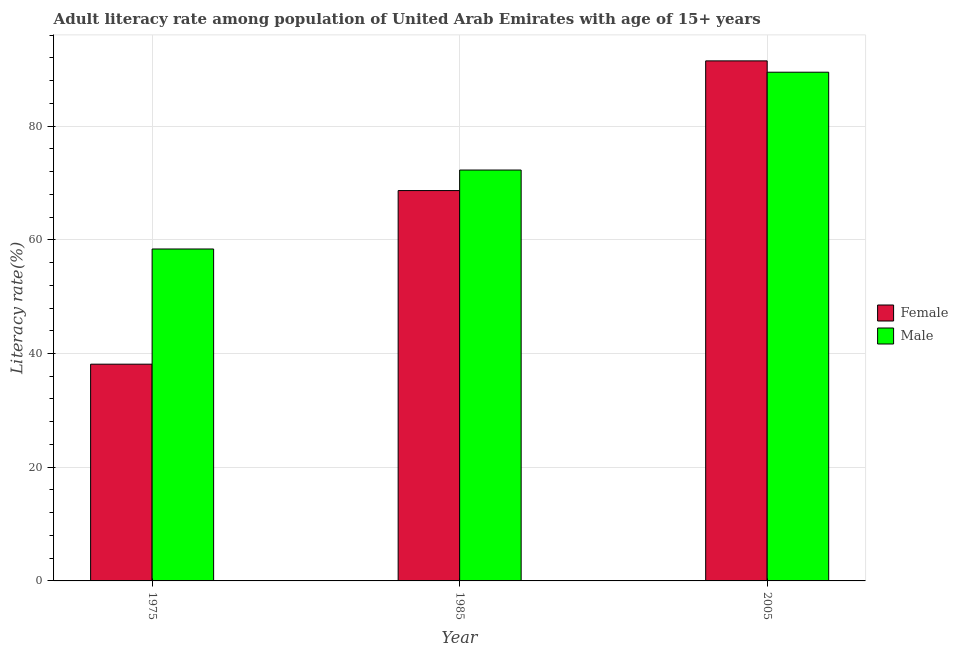How many different coloured bars are there?
Your answer should be very brief. 2. How many groups of bars are there?
Offer a terse response. 3. Are the number of bars per tick equal to the number of legend labels?
Ensure brevity in your answer.  Yes. Are the number of bars on each tick of the X-axis equal?
Your response must be concise. Yes. How many bars are there on the 1st tick from the right?
Provide a succinct answer. 2. What is the label of the 3rd group of bars from the left?
Your answer should be compact. 2005. In how many cases, is the number of bars for a given year not equal to the number of legend labels?
Give a very brief answer. 0. What is the male adult literacy rate in 1975?
Keep it short and to the point. 58.39. Across all years, what is the maximum female adult literacy rate?
Your answer should be very brief. 91.47. Across all years, what is the minimum male adult literacy rate?
Your answer should be compact. 58.39. In which year was the male adult literacy rate maximum?
Keep it short and to the point. 2005. In which year was the female adult literacy rate minimum?
Your answer should be compact. 1975. What is the total male adult literacy rate in the graph?
Provide a short and direct response. 220.14. What is the difference between the male adult literacy rate in 1985 and that in 2005?
Give a very brief answer. -17.21. What is the difference between the female adult literacy rate in 1975 and the male adult literacy rate in 2005?
Provide a short and direct response. -53.35. What is the average female adult literacy rate per year?
Keep it short and to the point. 66.09. In how many years, is the male adult literacy rate greater than 40 %?
Keep it short and to the point. 3. What is the ratio of the female adult literacy rate in 1975 to that in 2005?
Keep it short and to the point. 0.42. Is the male adult literacy rate in 1985 less than that in 2005?
Give a very brief answer. Yes. What is the difference between the highest and the second highest male adult literacy rate?
Keep it short and to the point. 17.21. What is the difference between the highest and the lowest male adult literacy rate?
Your answer should be compact. 31.1. Is the sum of the female adult literacy rate in 1975 and 2005 greater than the maximum male adult literacy rate across all years?
Offer a very short reply. Yes. What does the 1st bar from the left in 1975 represents?
Provide a short and direct response. Female. Are all the bars in the graph horizontal?
Make the answer very short. No. Are the values on the major ticks of Y-axis written in scientific E-notation?
Your response must be concise. No. Where does the legend appear in the graph?
Your response must be concise. Center right. How many legend labels are there?
Provide a short and direct response. 2. How are the legend labels stacked?
Make the answer very short. Vertical. What is the title of the graph?
Offer a very short reply. Adult literacy rate among population of United Arab Emirates with age of 15+ years. What is the label or title of the X-axis?
Give a very brief answer. Year. What is the label or title of the Y-axis?
Give a very brief answer. Literacy rate(%). What is the Literacy rate(%) in Female in 1975?
Your answer should be very brief. 38.12. What is the Literacy rate(%) in Male in 1975?
Your answer should be compact. 58.39. What is the Literacy rate(%) in Female in 1985?
Offer a very short reply. 68.66. What is the Literacy rate(%) in Male in 1985?
Give a very brief answer. 72.27. What is the Literacy rate(%) in Female in 2005?
Offer a very short reply. 91.47. What is the Literacy rate(%) in Male in 2005?
Offer a very short reply. 89.48. Across all years, what is the maximum Literacy rate(%) in Female?
Offer a very short reply. 91.47. Across all years, what is the maximum Literacy rate(%) in Male?
Provide a succinct answer. 89.48. Across all years, what is the minimum Literacy rate(%) of Female?
Your response must be concise. 38.12. Across all years, what is the minimum Literacy rate(%) of Male?
Keep it short and to the point. 58.39. What is the total Literacy rate(%) in Female in the graph?
Offer a terse response. 198.26. What is the total Literacy rate(%) of Male in the graph?
Make the answer very short. 220.14. What is the difference between the Literacy rate(%) in Female in 1975 and that in 1985?
Ensure brevity in your answer.  -30.54. What is the difference between the Literacy rate(%) of Male in 1975 and that in 1985?
Give a very brief answer. -13.89. What is the difference between the Literacy rate(%) of Female in 1975 and that in 2005?
Provide a succinct answer. -53.35. What is the difference between the Literacy rate(%) in Male in 1975 and that in 2005?
Make the answer very short. -31.1. What is the difference between the Literacy rate(%) of Female in 1985 and that in 2005?
Ensure brevity in your answer.  -22.81. What is the difference between the Literacy rate(%) of Male in 1985 and that in 2005?
Your answer should be compact. -17.21. What is the difference between the Literacy rate(%) of Female in 1975 and the Literacy rate(%) of Male in 1985?
Give a very brief answer. -34.15. What is the difference between the Literacy rate(%) in Female in 1975 and the Literacy rate(%) in Male in 2005?
Keep it short and to the point. -51.36. What is the difference between the Literacy rate(%) in Female in 1985 and the Literacy rate(%) in Male in 2005?
Offer a very short reply. -20.82. What is the average Literacy rate(%) of Female per year?
Your answer should be very brief. 66.09. What is the average Literacy rate(%) in Male per year?
Make the answer very short. 73.38. In the year 1975, what is the difference between the Literacy rate(%) of Female and Literacy rate(%) of Male?
Offer a terse response. -20.26. In the year 1985, what is the difference between the Literacy rate(%) of Female and Literacy rate(%) of Male?
Provide a short and direct response. -3.61. In the year 2005, what is the difference between the Literacy rate(%) of Female and Literacy rate(%) of Male?
Provide a short and direct response. 1.99. What is the ratio of the Literacy rate(%) of Female in 1975 to that in 1985?
Ensure brevity in your answer.  0.56. What is the ratio of the Literacy rate(%) in Male in 1975 to that in 1985?
Provide a short and direct response. 0.81. What is the ratio of the Literacy rate(%) of Female in 1975 to that in 2005?
Provide a succinct answer. 0.42. What is the ratio of the Literacy rate(%) in Male in 1975 to that in 2005?
Make the answer very short. 0.65. What is the ratio of the Literacy rate(%) of Female in 1985 to that in 2005?
Make the answer very short. 0.75. What is the ratio of the Literacy rate(%) in Male in 1985 to that in 2005?
Your answer should be very brief. 0.81. What is the difference between the highest and the second highest Literacy rate(%) in Female?
Your answer should be very brief. 22.81. What is the difference between the highest and the second highest Literacy rate(%) of Male?
Your answer should be compact. 17.21. What is the difference between the highest and the lowest Literacy rate(%) of Female?
Offer a very short reply. 53.35. What is the difference between the highest and the lowest Literacy rate(%) of Male?
Ensure brevity in your answer.  31.1. 